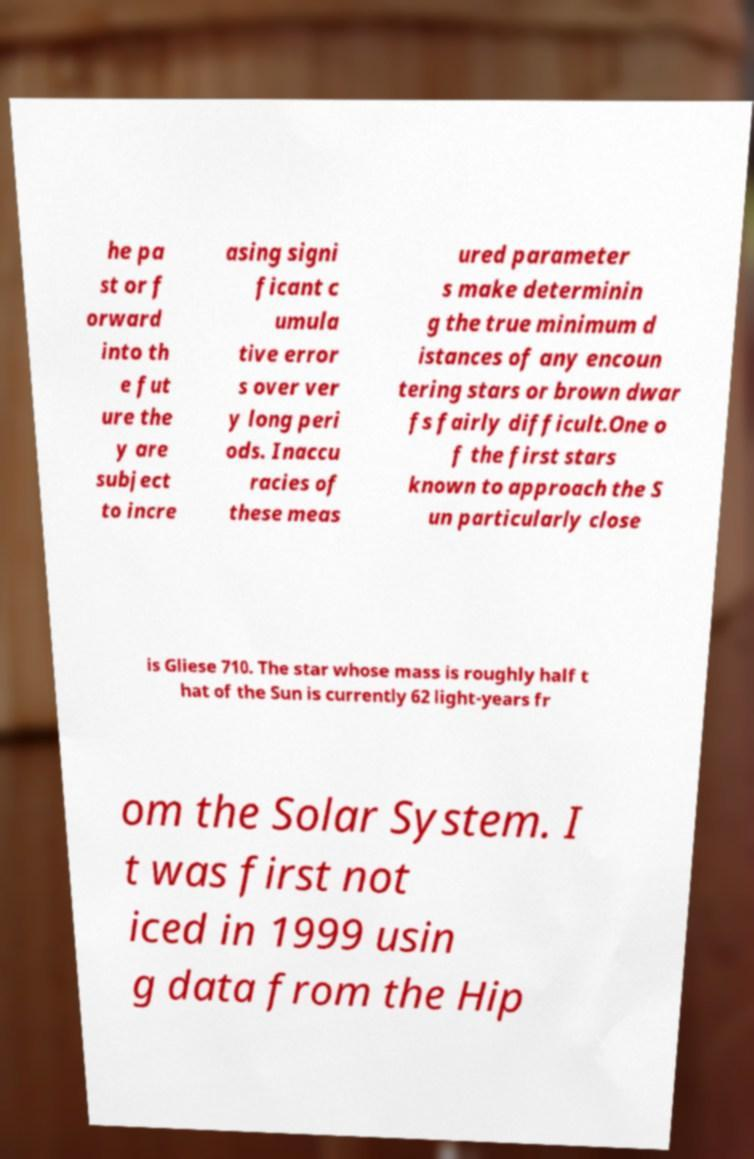Can you read and provide the text displayed in the image?This photo seems to have some interesting text. Can you extract and type it out for me? he pa st or f orward into th e fut ure the y are subject to incre asing signi ficant c umula tive error s over ver y long peri ods. Inaccu racies of these meas ured parameter s make determinin g the true minimum d istances of any encoun tering stars or brown dwar fs fairly difficult.One o f the first stars known to approach the S un particularly close is Gliese 710. The star whose mass is roughly half t hat of the Sun is currently 62 light-years fr om the Solar System. I t was first not iced in 1999 usin g data from the Hip 